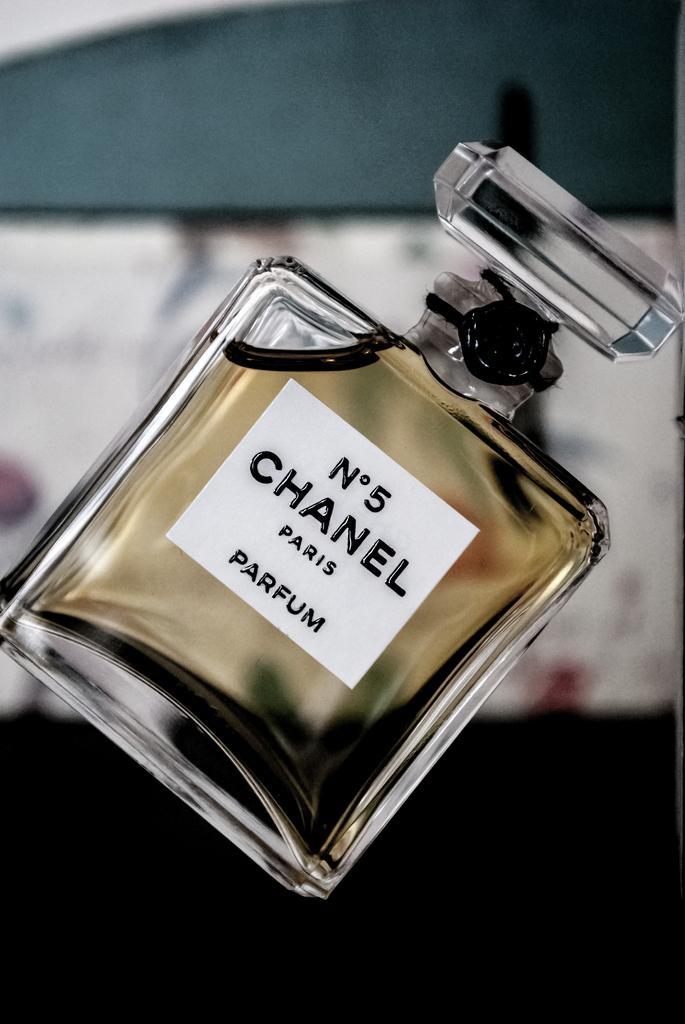Could you give a brief overview of what you see in this image? In this picture we can observe a perfume bottle which is in square shape. We can observe a white color sticker on the bottle. The perfume is in pale yellow color. In the background it is completely blur. 